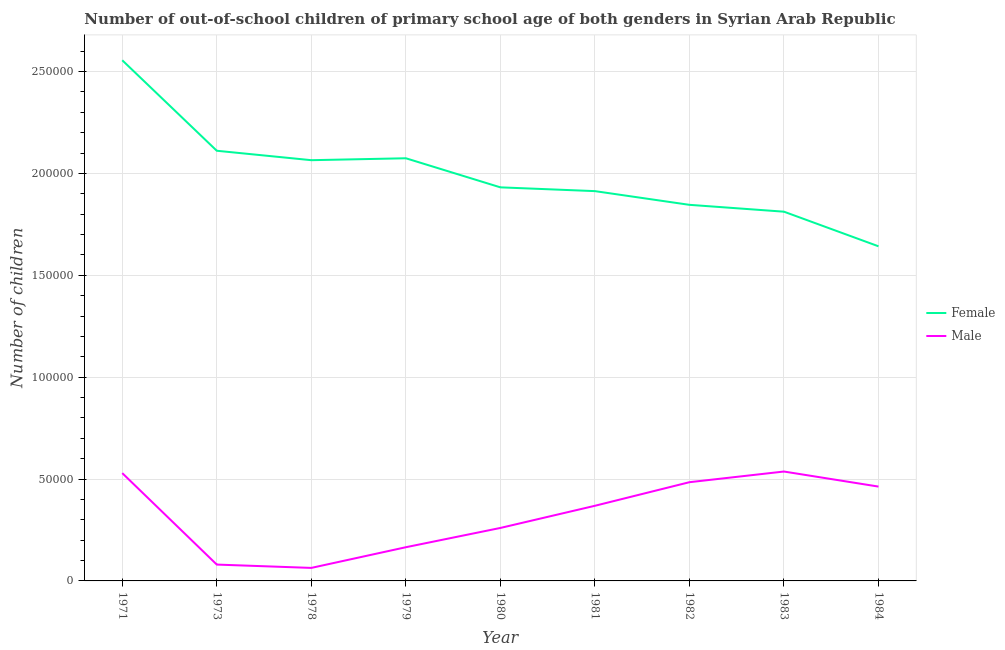How many different coloured lines are there?
Your response must be concise. 2. Does the line corresponding to number of male out-of-school students intersect with the line corresponding to number of female out-of-school students?
Give a very brief answer. No. Is the number of lines equal to the number of legend labels?
Give a very brief answer. Yes. What is the number of male out-of-school students in 1978?
Keep it short and to the point. 6389. Across all years, what is the maximum number of male out-of-school students?
Ensure brevity in your answer.  5.37e+04. Across all years, what is the minimum number of male out-of-school students?
Ensure brevity in your answer.  6389. In which year was the number of female out-of-school students maximum?
Your answer should be compact. 1971. In which year was the number of male out-of-school students minimum?
Offer a very short reply. 1978. What is the total number of female out-of-school students in the graph?
Your answer should be very brief. 1.80e+06. What is the difference between the number of male out-of-school students in 1978 and that in 1981?
Offer a terse response. -3.05e+04. What is the difference between the number of female out-of-school students in 1982 and the number of male out-of-school students in 1971?
Offer a terse response. 1.32e+05. What is the average number of female out-of-school students per year?
Provide a short and direct response. 1.99e+05. In the year 1973, what is the difference between the number of male out-of-school students and number of female out-of-school students?
Offer a very short reply. -2.03e+05. What is the ratio of the number of female out-of-school students in 1978 to that in 1979?
Give a very brief answer. 1. What is the difference between the highest and the second highest number of female out-of-school students?
Make the answer very short. 4.44e+04. What is the difference between the highest and the lowest number of female out-of-school students?
Offer a terse response. 9.13e+04. In how many years, is the number of male out-of-school students greater than the average number of male out-of-school students taken over all years?
Your answer should be compact. 5. Is the number of male out-of-school students strictly greater than the number of female out-of-school students over the years?
Ensure brevity in your answer.  No. Is the number of male out-of-school students strictly less than the number of female out-of-school students over the years?
Offer a terse response. Yes. How many lines are there?
Offer a terse response. 2. What is the difference between two consecutive major ticks on the Y-axis?
Offer a terse response. 5.00e+04. Does the graph contain any zero values?
Your answer should be compact. No. Where does the legend appear in the graph?
Keep it short and to the point. Center right. What is the title of the graph?
Your answer should be very brief. Number of out-of-school children of primary school age of both genders in Syrian Arab Republic. Does "Time to import" appear as one of the legend labels in the graph?
Ensure brevity in your answer.  No. What is the label or title of the X-axis?
Give a very brief answer. Year. What is the label or title of the Y-axis?
Provide a short and direct response. Number of children. What is the Number of children of Female in 1971?
Your answer should be very brief. 2.56e+05. What is the Number of children in Male in 1971?
Give a very brief answer. 5.29e+04. What is the Number of children in Female in 1973?
Provide a short and direct response. 2.11e+05. What is the Number of children in Male in 1973?
Your answer should be compact. 8023. What is the Number of children of Female in 1978?
Offer a terse response. 2.06e+05. What is the Number of children in Male in 1978?
Make the answer very short. 6389. What is the Number of children in Female in 1979?
Give a very brief answer. 2.07e+05. What is the Number of children in Male in 1979?
Offer a terse response. 1.65e+04. What is the Number of children of Female in 1980?
Offer a terse response. 1.93e+05. What is the Number of children of Male in 1980?
Provide a short and direct response. 2.60e+04. What is the Number of children in Female in 1981?
Your answer should be very brief. 1.91e+05. What is the Number of children in Male in 1981?
Offer a very short reply. 3.69e+04. What is the Number of children of Female in 1982?
Your response must be concise. 1.85e+05. What is the Number of children in Male in 1982?
Your answer should be very brief. 4.85e+04. What is the Number of children in Female in 1983?
Give a very brief answer. 1.81e+05. What is the Number of children in Male in 1983?
Ensure brevity in your answer.  5.37e+04. What is the Number of children in Female in 1984?
Ensure brevity in your answer.  1.64e+05. What is the Number of children in Male in 1984?
Your response must be concise. 4.63e+04. Across all years, what is the maximum Number of children in Female?
Keep it short and to the point. 2.56e+05. Across all years, what is the maximum Number of children of Male?
Your answer should be compact. 5.37e+04. Across all years, what is the minimum Number of children in Female?
Ensure brevity in your answer.  1.64e+05. Across all years, what is the minimum Number of children of Male?
Make the answer very short. 6389. What is the total Number of children of Female in the graph?
Your answer should be compact. 1.80e+06. What is the total Number of children of Male in the graph?
Your answer should be very brief. 2.95e+05. What is the difference between the Number of children of Female in 1971 and that in 1973?
Your response must be concise. 4.44e+04. What is the difference between the Number of children in Male in 1971 and that in 1973?
Keep it short and to the point. 4.49e+04. What is the difference between the Number of children in Female in 1971 and that in 1978?
Provide a short and direct response. 4.90e+04. What is the difference between the Number of children in Male in 1971 and that in 1978?
Keep it short and to the point. 4.65e+04. What is the difference between the Number of children of Female in 1971 and that in 1979?
Provide a succinct answer. 4.81e+04. What is the difference between the Number of children in Male in 1971 and that in 1979?
Your response must be concise. 3.64e+04. What is the difference between the Number of children in Female in 1971 and that in 1980?
Your response must be concise. 6.24e+04. What is the difference between the Number of children in Male in 1971 and that in 1980?
Provide a short and direct response. 2.69e+04. What is the difference between the Number of children in Female in 1971 and that in 1981?
Give a very brief answer. 6.42e+04. What is the difference between the Number of children of Male in 1971 and that in 1981?
Your answer should be compact. 1.60e+04. What is the difference between the Number of children of Female in 1971 and that in 1982?
Provide a succinct answer. 7.10e+04. What is the difference between the Number of children in Male in 1971 and that in 1982?
Make the answer very short. 4457. What is the difference between the Number of children of Female in 1971 and that in 1983?
Provide a short and direct response. 7.43e+04. What is the difference between the Number of children in Male in 1971 and that in 1983?
Ensure brevity in your answer.  -777. What is the difference between the Number of children of Female in 1971 and that in 1984?
Give a very brief answer. 9.13e+04. What is the difference between the Number of children of Male in 1971 and that in 1984?
Ensure brevity in your answer.  6612. What is the difference between the Number of children in Female in 1973 and that in 1978?
Provide a short and direct response. 4629. What is the difference between the Number of children in Male in 1973 and that in 1978?
Ensure brevity in your answer.  1634. What is the difference between the Number of children of Female in 1973 and that in 1979?
Your answer should be compact. 3683. What is the difference between the Number of children in Male in 1973 and that in 1979?
Give a very brief answer. -8513. What is the difference between the Number of children in Female in 1973 and that in 1980?
Your answer should be compact. 1.80e+04. What is the difference between the Number of children of Male in 1973 and that in 1980?
Ensure brevity in your answer.  -1.80e+04. What is the difference between the Number of children of Female in 1973 and that in 1981?
Provide a short and direct response. 1.98e+04. What is the difference between the Number of children of Male in 1973 and that in 1981?
Provide a succinct answer. -2.89e+04. What is the difference between the Number of children in Female in 1973 and that in 1982?
Give a very brief answer. 2.65e+04. What is the difference between the Number of children in Male in 1973 and that in 1982?
Provide a short and direct response. -4.04e+04. What is the difference between the Number of children in Female in 1973 and that in 1983?
Give a very brief answer. 2.99e+04. What is the difference between the Number of children in Male in 1973 and that in 1983?
Provide a short and direct response. -4.57e+04. What is the difference between the Number of children in Female in 1973 and that in 1984?
Make the answer very short. 4.69e+04. What is the difference between the Number of children of Male in 1973 and that in 1984?
Your answer should be compact. -3.83e+04. What is the difference between the Number of children of Female in 1978 and that in 1979?
Ensure brevity in your answer.  -946. What is the difference between the Number of children of Male in 1978 and that in 1979?
Your answer should be compact. -1.01e+04. What is the difference between the Number of children in Female in 1978 and that in 1980?
Give a very brief answer. 1.33e+04. What is the difference between the Number of children in Male in 1978 and that in 1980?
Ensure brevity in your answer.  -1.96e+04. What is the difference between the Number of children of Female in 1978 and that in 1981?
Offer a terse response. 1.52e+04. What is the difference between the Number of children of Male in 1978 and that in 1981?
Provide a succinct answer. -3.05e+04. What is the difference between the Number of children in Female in 1978 and that in 1982?
Provide a short and direct response. 2.19e+04. What is the difference between the Number of children of Male in 1978 and that in 1982?
Your answer should be compact. -4.21e+04. What is the difference between the Number of children in Female in 1978 and that in 1983?
Offer a terse response. 2.53e+04. What is the difference between the Number of children in Male in 1978 and that in 1983?
Provide a succinct answer. -4.73e+04. What is the difference between the Number of children of Female in 1978 and that in 1984?
Your answer should be very brief. 4.23e+04. What is the difference between the Number of children in Male in 1978 and that in 1984?
Your response must be concise. -3.99e+04. What is the difference between the Number of children of Female in 1979 and that in 1980?
Offer a terse response. 1.43e+04. What is the difference between the Number of children of Male in 1979 and that in 1980?
Provide a short and direct response. -9461. What is the difference between the Number of children of Female in 1979 and that in 1981?
Offer a terse response. 1.61e+04. What is the difference between the Number of children in Male in 1979 and that in 1981?
Offer a terse response. -2.03e+04. What is the difference between the Number of children of Female in 1979 and that in 1982?
Make the answer very short. 2.29e+04. What is the difference between the Number of children of Male in 1979 and that in 1982?
Provide a succinct answer. -3.19e+04. What is the difference between the Number of children of Female in 1979 and that in 1983?
Provide a succinct answer. 2.62e+04. What is the difference between the Number of children in Male in 1979 and that in 1983?
Keep it short and to the point. -3.72e+04. What is the difference between the Number of children of Female in 1979 and that in 1984?
Keep it short and to the point. 4.32e+04. What is the difference between the Number of children of Male in 1979 and that in 1984?
Provide a short and direct response. -2.98e+04. What is the difference between the Number of children of Female in 1980 and that in 1981?
Your answer should be very brief. 1853. What is the difference between the Number of children of Male in 1980 and that in 1981?
Make the answer very short. -1.09e+04. What is the difference between the Number of children in Female in 1980 and that in 1982?
Offer a terse response. 8580. What is the difference between the Number of children of Male in 1980 and that in 1982?
Your response must be concise. -2.25e+04. What is the difference between the Number of children in Female in 1980 and that in 1983?
Provide a short and direct response. 1.19e+04. What is the difference between the Number of children in Male in 1980 and that in 1983?
Your answer should be very brief. -2.77e+04. What is the difference between the Number of children in Female in 1980 and that in 1984?
Give a very brief answer. 2.89e+04. What is the difference between the Number of children in Male in 1980 and that in 1984?
Keep it short and to the point. -2.03e+04. What is the difference between the Number of children in Female in 1981 and that in 1982?
Provide a short and direct response. 6727. What is the difference between the Number of children in Male in 1981 and that in 1982?
Give a very brief answer. -1.16e+04. What is the difference between the Number of children of Female in 1981 and that in 1983?
Offer a very short reply. 1.01e+04. What is the difference between the Number of children of Male in 1981 and that in 1983?
Provide a short and direct response. -1.68e+04. What is the difference between the Number of children in Female in 1981 and that in 1984?
Your response must be concise. 2.71e+04. What is the difference between the Number of children of Male in 1981 and that in 1984?
Offer a terse response. -9422. What is the difference between the Number of children in Female in 1982 and that in 1983?
Ensure brevity in your answer.  3367. What is the difference between the Number of children of Male in 1982 and that in 1983?
Keep it short and to the point. -5234. What is the difference between the Number of children in Female in 1982 and that in 1984?
Keep it short and to the point. 2.04e+04. What is the difference between the Number of children in Male in 1982 and that in 1984?
Provide a short and direct response. 2155. What is the difference between the Number of children in Female in 1983 and that in 1984?
Your answer should be compact. 1.70e+04. What is the difference between the Number of children of Male in 1983 and that in 1984?
Your response must be concise. 7389. What is the difference between the Number of children of Female in 1971 and the Number of children of Male in 1973?
Offer a terse response. 2.48e+05. What is the difference between the Number of children in Female in 1971 and the Number of children in Male in 1978?
Give a very brief answer. 2.49e+05. What is the difference between the Number of children of Female in 1971 and the Number of children of Male in 1979?
Offer a terse response. 2.39e+05. What is the difference between the Number of children in Female in 1971 and the Number of children in Male in 1980?
Your answer should be very brief. 2.30e+05. What is the difference between the Number of children of Female in 1971 and the Number of children of Male in 1981?
Give a very brief answer. 2.19e+05. What is the difference between the Number of children in Female in 1971 and the Number of children in Male in 1982?
Give a very brief answer. 2.07e+05. What is the difference between the Number of children of Female in 1971 and the Number of children of Male in 1983?
Provide a short and direct response. 2.02e+05. What is the difference between the Number of children in Female in 1971 and the Number of children in Male in 1984?
Keep it short and to the point. 2.09e+05. What is the difference between the Number of children in Female in 1973 and the Number of children in Male in 1978?
Your answer should be compact. 2.05e+05. What is the difference between the Number of children of Female in 1973 and the Number of children of Male in 1979?
Keep it short and to the point. 1.95e+05. What is the difference between the Number of children in Female in 1973 and the Number of children in Male in 1980?
Your answer should be compact. 1.85e+05. What is the difference between the Number of children of Female in 1973 and the Number of children of Male in 1981?
Your response must be concise. 1.74e+05. What is the difference between the Number of children of Female in 1973 and the Number of children of Male in 1982?
Your response must be concise. 1.63e+05. What is the difference between the Number of children in Female in 1973 and the Number of children in Male in 1983?
Give a very brief answer. 1.57e+05. What is the difference between the Number of children of Female in 1973 and the Number of children of Male in 1984?
Keep it short and to the point. 1.65e+05. What is the difference between the Number of children in Female in 1978 and the Number of children in Male in 1979?
Make the answer very short. 1.90e+05. What is the difference between the Number of children of Female in 1978 and the Number of children of Male in 1980?
Your answer should be compact. 1.80e+05. What is the difference between the Number of children of Female in 1978 and the Number of children of Male in 1981?
Keep it short and to the point. 1.70e+05. What is the difference between the Number of children in Female in 1978 and the Number of children in Male in 1982?
Your answer should be very brief. 1.58e+05. What is the difference between the Number of children of Female in 1978 and the Number of children of Male in 1983?
Give a very brief answer. 1.53e+05. What is the difference between the Number of children of Female in 1978 and the Number of children of Male in 1984?
Ensure brevity in your answer.  1.60e+05. What is the difference between the Number of children in Female in 1979 and the Number of children in Male in 1980?
Make the answer very short. 1.81e+05. What is the difference between the Number of children of Female in 1979 and the Number of children of Male in 1981?
Provide a short and direct response. 1.71e+05. What is the difference between the Number of children of Female in 1979 and the Number of children of Male in 1982?
Provide a short and direct response. 1.59e+05. What is the difference between the Number of children in Female in 1979 and the Number of children in Male in 1983?
Provide a succinct answer. 1.54e+05. What is the difference between the Number of children in Female in 1979 and the Number of children in Male in 1984?
Offer a terse response. 1.61e+05. What is the difference between the Number of children in Female in 1980 and the Number of children in Male in 1981?
Provide a short and direct response. 1.56e+05. What is the difference between the Number of children in Female in 1980 and the Number of children in Male in 1982?
Provide a succinct answer. 1.45e+05. What is the difference between the Number of children in Female in 1980 and the Number of children in Male in 1983?
Offer a terse response. 1.39e+05. What is the difference between the Number of children of Female in 1980 and the Number of children of Male in 1984?
Your answer should be compact. 1.47e+05. What is the difference between the Number of children in Female in 1981 and the Number of children in Male in 1982?
Provide a succinct answer. 1.43e+05. What is the difference between the Number of children of Female in 1981 and the Number of children of Male in 1983?
Offer a terse response. 1.38e+05. What is the difference between the Number of children of Female in 1981 and the Number of children of Male in 1984?
Your response must be concise. 1.45e+05. What is the difference between the Number of children in Female in 1982 and the Number of children in Male in 1983?
Your answer should be very brief. 1.31e+05. What is the difference between the Number of children of Female in 1982 and the Number of children of Male in 1984?
Ensure brevity in your answer.  1.38e+05. What is the difference between the Number of children in Female in 1983 and the Number of children in Male in 1984?
Your answer should be very brief. 1.35e+05. What is the average Number of children in Female per year?
Your answer should be very brief. 1.99e+05. What is the average Number of children in Male per year?
Ensure brevity in your answer.  3.28e+04. In the year 1971, what is the difference between the Number of children of Female and Number of children of Male?
Offer a terse response. 2.03e+05. In the year 1973, what is the difference between the Number of children of Female and Number of children of Male?
Your answer should be very brief. 2.03e+05. In the year 1978, what is the difference between the Number of children in Female and Number of children in Male?
Provide a short and direct response. 2.00e+05. In the year 1979, what is the difference between the Number of children in Female and Number of children in Male?
Provide a short and direct response. 1.91e+05. In the year 1980, what is the difference between the Number of children of Female and Number of children of Male?
Your response must be concise. 1.67e+05. In the year 1981, what is the difference between the Number of children of Female and Number of children of Male?
Provide a succinct answer. 1.54e+05. In the year 1982, what is the difference between the Number of children in Female and Number of children in Male?
Provide a succinct answer. 1.36e+05. In the year 1983, what is the difference between the Number of children in Female and Number of children in Male?
Make the answer very short. 1.28e+05. In the year 1984, what is the difference between the Number of children in Female and Number of children in Male?
Provide a succinct answer. 1.18e+05. What is the ratio of the Number of children of Female in 1971 to that in 1973?
Give a very brief answer. 1.21. What is the ratio of the Number of children of Male in 1971 to that in 1973?
Give a very brief answer. 6.59. What is the ratio of the Number of children of Female in 1971 to that in 1978?
Offer a terse response. 1.24. What is the ratio of the Number of children of Male in 1971 to that in 1978?
Ensure brevity in your answer.  8.28. What is the ratio of the Number of children of Female in 1971 to that in 1979?
Your answer should be very brief. 1.23. What is the ratio of the Number of children of Male in 1971 to that in 1979?
Ensure brevity in your answer.  3.2. What is the ratio of the Number of children of Female in 1971 to that in 1980?
Provide a short and direct response. 1.32. What is the ratio of the Number of children in Male in 1971 to that in 1980?
Offer a very short reply. 2.04. What is the ratio of the Number of children of Female in 1971 to that in 1981?
Offer a very short reply. 1.34. What is the ratio of the Number of children in Male in 1971 to that in 1981?
Give a very brief answer. 1.43. What is the ratio of the Number of children of Female in 1971 to that in 1982?
Offer a terse response. 1.38. What is the ratio of the Number of children of Male in 1971 to that in 1982?
Make the answer very short. 1.09. What is the ratio of the Number of children in Female in 1971 to that in 1983?
Offer a terse response. 1.41. What is the ratio of the Number of children in Male in 1971 to that in 1983?
Offer a terse response. 0.99. What is the ratio of the Number of children in Female in 1971 to that in 1984?
Keep it short and to the point. 1.56. What is the ratio of the Number of children in Male in 1971 to that in 1984?
Give a very brief answer. 1.14. What is the ratio of the Number of children in Female in 1973 to that in 1978?
Ensure brevity in your answer.  1.02. What is the ratio of the Number of children in Male in 1973 to that in 1978?
Offer a terse response. 1.26. What is the ratio of the Number of children in Female in 1973 to that in 1979?
Offer a very short reply. 1.02. What is the ratio of the Number of children in Male in 1973 to that in 1979?
Give a very brief answer. 0.49. What is the ratio of the Number of children in Female in 1973 to that in 1980?
Provide a succinct answer. 1.09. What is the ratio of the Number of children in Male in 1973 to that in 1980?
Give a very brief answer. 0.31. What is the ratio of the Number of children of Female in 1973 to that in 1981?
Make the answer very short. 1.1. What is the ratio of the Number of children in Male in 1973 to that in 1981?
Your answer should be compact. 0.22. What is the ratio of the Number of children of Female in 1973 to that in 1982?
Your response must be concise. 1.14. What is the ratio of the Number of children of Male in 1973 to that in 1982?
Offer a very short reply. 0.17. What is the ratio of the Number of children in Female in 1973 to that in 1983?
Your answer should be very brief. 1.17. What is the ratio of the Number of children of Male in 1973 to that in 1983?
Give a very brief answer. 0.15. What is the ratio of the Number of children of Female in 1973 to that in 1984?
Offer a terse response. 1.29. What is the ratio of the Number of children of Male in 1973 to that in 1984?
Make the answer very short. 0.17. What is the ratio of the Number of children in Female in 1978 to that in 1979?
Your answer should be compact. 1. What is the ratio of the Number of children in Male in 1978 to that in 1979?
Provide a succinct answer. 0.39. What is the ratio of the Number of children in Female in 1978 to that in 1980?
Your answer should be compact. 1.07. What is the ratio of the Number of children in Male in 1978 to that in 1980?
Your answer should be compact. 0.25. What is the ratio of the Number of children in Female in 1978 to that in 1981?
Keep it short and to the point. 1.08. What is the ratio of the Number of children in Male in 1978 to that in 1981?
Offer a terse response. 0.17. What is the ratio of the Number of children in Female in 1978 to that in 1982?
Offer a very short reply. 1.12. What is the ratio of the Number of children of Male in 1978 to that in 1982?
Your response must be concise. 0.13. What is the ratio of the Number of children in Female in 1978 to that in 1983?
Ensure brevity in your answer.  1.14. What is the ratio of the Number of children of Male in 1978 to that in 1983?
Give a very brief answer. 0.12. What is the ratio of the Number of children in Female in 1978 to that in 1984?
Make the answer very short. 1.26. What is the ratio of the Number of children in Male in 1978 to that in 1984?
Your answer should be compact. 0.14. What is the ratio of the Number of children in Female in 1979 to that in 1980?
Give a very brief answer. 1.07. What is the ratio of the Number of children in Male in 1979 to that in 1980?
Your answer should be very brief. 0.64. What is the ratio of the Number of children of Female in 1979 to that in 1981?
Offer a terse response. 1.08. What is the ratio of the Number of children of Male in 1979 to that in 1981?
Your response must be concise. 0.45. What is the ratio of the Number of children in Female in 1979 to that in 1982?
Provide a succinct answer. 1.12. What is the ratio of the Number of children in Male in 1979 to that in 1982?
Give a very brief answer. 0.34. What is the ratio of the Number of children of Female in 1979 to that in 1983?
Provide a succinct answer. 1.14. What is the ratio of the Number of children in Male in 1979 to that in 1983?
Your response must be concise. 0.31. What is the ratio of the Number of children of Female in 1979 to that in 1984?
Provide a succinct answer. 1.26. What is the ratio of the Number of children of Male in 1979 to that in 1984?
Your response must be concise. 0.36. What is the ratio of the Number of children in Female in 1980 to that in 1981?
Provide a short and direct response. 1.01. What is the ratio of the Number of children in Male in 1980 to that in 1981?
Your answer should be very brief. 0.7. What is the ratio of the Number of children in Female in 1980 to that in 1982?
Keep it short and to the point. 1.05. What is the ratio of the Number of children of Male in 1980 to that in 1982?
Make the answer very short. 0.54. What is the ratio of the Number of children in Female in 1980 to that in 1983?
Your answer should be compact. 1.07. What is the ratio of the Number of children of Male in 1980 to that in 1983?
Offer a terse response. 0.48. What is the ratio of the Number of children of Female in 1980 to that in 1984?
Offer a terse response. 1.18. What is the ratio of the Number of children in Male in 1980 to that in 1984?
Offer a terse response. 0.56. What is the ratio of the Number of children of Female in 1981 to that in 1982?
Provide a short and direct response. 1.04. What is the ratio of the Number of children in Male in 1981 to that in 1982?
Your response must be concise. 0.76. What is the ratio of the Number of children in Female in 1981 to that in 1983?
Provide a succinct answer. 1.06. What is the ratio of the Number of children of Male in 1981 to that in 1983?
Offer a terse response. 0.69. What is the ratio of the Number of children in Female in 1981 to that in 1984?
Give a very brief answer. 1.16. What is the ratio of the Number of children of Male in 1981 to that in 1984?
Provide a short and direct response. 0.8. What is the ratio of the Number of children of Female in 1982 to that in 1983?
Make the answer very short. 1.02. What is the ratio of the Number of children of Male in 1982 to that in 1983?
Your answer should be compact. 0.9. What is the ratio of the Number of children in Female in 1982 to that in 1984?
Give a very brief answer. 1.12. What is the ratio of the Number of children in Male in 1982 to that in 1984?
Your response must be concise. 1.05. What is the ratio of the Number of children of Female in 1983 to that in 1984?
Ensure brevity in your answer.  1.1. What is the ratio of the Number of children of Male in 1983 to that in 1984?
Ensure brevity in your answer.  1.16. What is the difference between the highest and the second highest Number of children of Female?
Keep it short and to the point. 4.44e+04. What is the difference between the highest and the second highest Number of children of Male?
Your answer should be very brief. 777. What is the difference between the highest and the lowest Number of children of Female?
Your response must be concise. 9.13e+04. What is the difference between the highest and the lowest Number of children in Male?
Provide a succinct answer. 4.73e+04. 